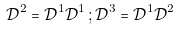<formula> <loc_0><loc_0><loc_500><loc_500>\mathcal { D } ^ { 2 } = \mathcal { D } ^ { 1 } \mathcal { D } ^ { 1 } \, ; \mathcal { D } ^ { 3 } = \mathcal { D } ^ { 1 } \mathcal { D } ^ { 2 }</formula> 